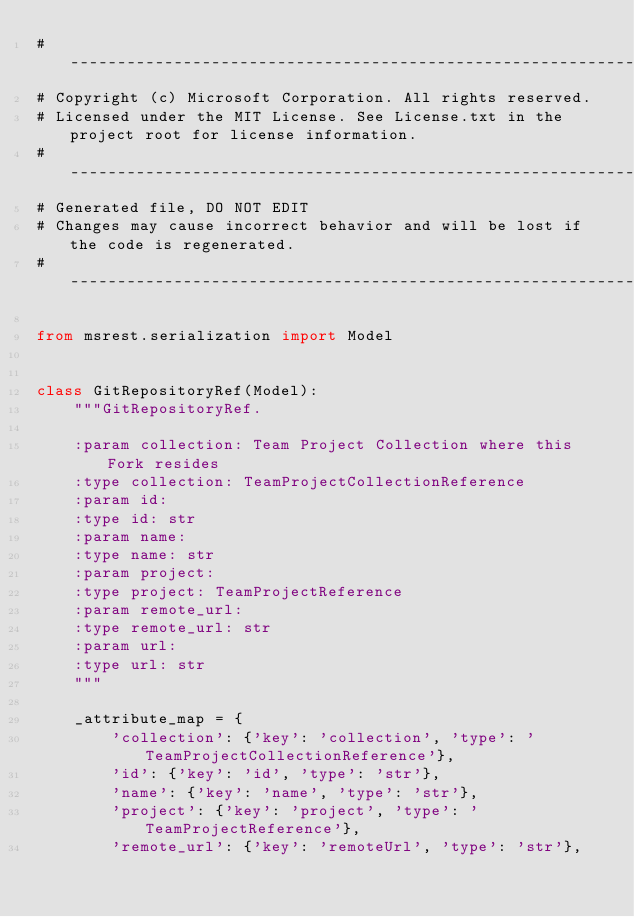Convert code to text. <code><loc_0><loc_0><loc_500><loc_500><_Python_># --------------------------------------------------------------------------------------------
# Copyright (c) Microsoft Corporation. All rights reserved.
# Licensed under the MIT License. See License.txt in the project root for license information.
# --------------------------------------------------------------------------------------------
# Generated file, DO NOT EDIT
# Changes may cause incorrect behavior and will be lost if the code is regenerated.
# --------------------------------------------------------------------------------------------

from msrest.serialization import Model


class GitRepositoryRef(Model):
    """GitRepositoryRef.

    :param collection: Team Project Collection where this Fork resides
    :type collection: TeamProjectCollectionReference
    :param id:
    :type id: str
    :param name:
    :type name: str
    :param project:
    :type project: TeamProjectReference
    :param remote_url:
    :type remote_url: str
    :param url:
    :type url: str
    """

    _attribute_map = {
        'collection': {'key': 'collection', 'type': 'TeamProjectCollectionReference'},
        'id': {'key': 'id', 'type': 'str'},
        'name': {'key': 'name', 'type': 'str'},
        'project': {'key': 'project', 'type': 'TeamProjectReference'},
        'remote_url': {'key': 'remoteUrl', 'type': 'str'},</code> 